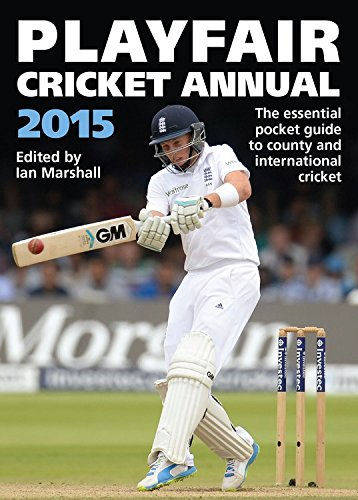Is this a comics book? No, this book is not a comic book but a sports reference guide focused on cricket. 